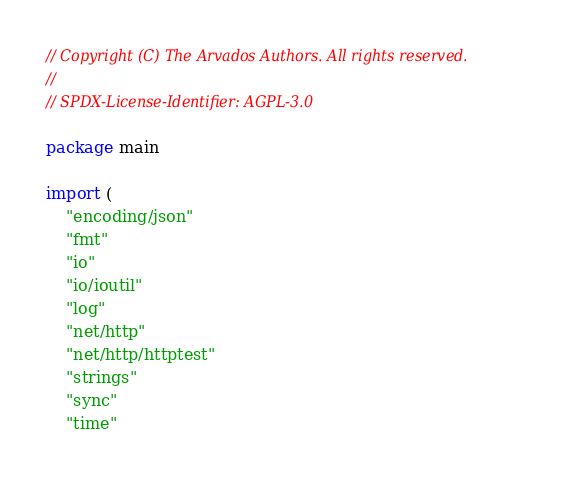<code> <loc_0><loc_0><loc_500><loc_500><_Go_>// Copyright (C) The Arvados Authors. All rights reserved.
//
// SPDX-License-Identifier: AGPL-3.0

package main

import (
	"encoding/json"
	"fmt"
	"io"
	"io/ioutil"
	"log"
	"net/http"
	"net/http/httptest"
	"strings"
	"sync"
	"time"
</code> 